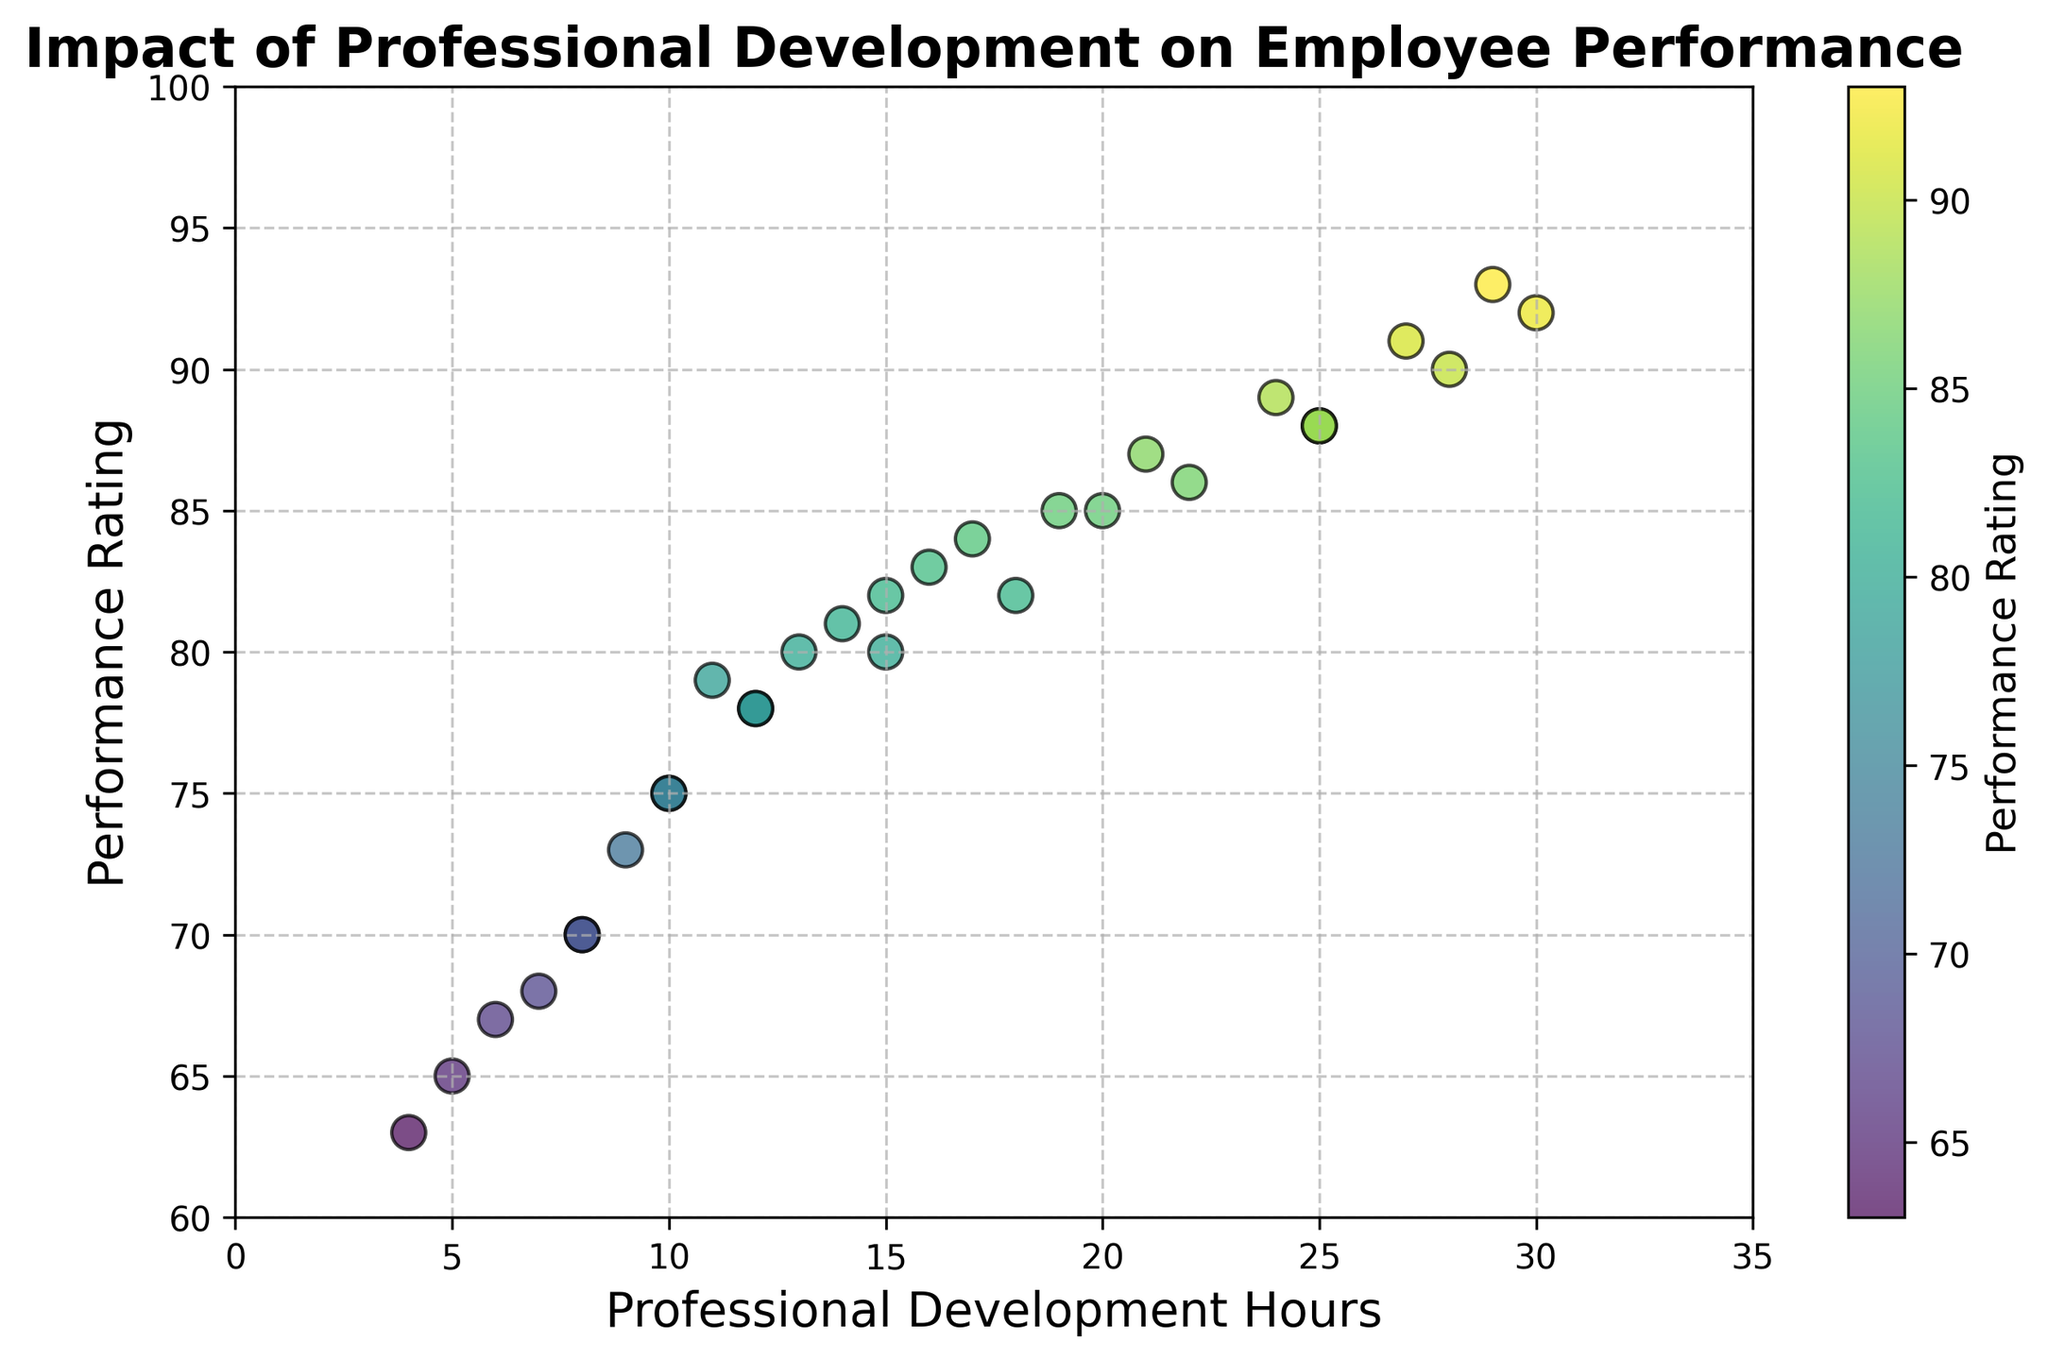How many employees have a performance rating above 85? By examining the y-axis and identifying points above the 85 mark, we count the number of points.
Answer: 8 Is there a noticeable trend between professional development hours and performance ratings? When looking at the scatter plot, you can see that as professional development hours increase (x-axis), the performance ratings (y-axis) generally also increase, indicating a positive relationship.
Answer: Yes, a positive trend Which employee had the highest performance rating and how many professional development hours did they complete? The highest performance rating on the y-axis is 93. Checking the corresponding x-axis value gives the number of professional development hours.
Answer: Employee with 29 hours What is the average performance rating for employees who completed at least 20 hours of professional development? Identify and sum the performance ratings of employees with 20+ hours of development, then divide by the count. Ratings: [85, 88, 92, 86, 88, 87, 89, 91, 93]. The sum is 709 and there are 9 employees, so 709/9 = 78.78
Answer: 88.67 Comparing employees with 10 hours and 25 hours of professional development, which group had higher average performance ratings? Look at the ratings for employees with exactly 10 hours (75, 75) and employees with exactly 25 hours (88, 88). Average for 10 hours: (75+75)/2 = 75, for 25 hours: (88+88)/2 = 88.
Answer: 25 hours group What is the range of professional development hours for employees with performance ratings between 80 and 85? Identify employees with performance ratings between 80 and 85, then find the minimum and maximum development hours: Ratings: [80, 80, 81, 82, 83, 84, 85, 85], Hours are [15, 13, 14, 18, 16, 17, 20, 19], range = 20-13.
Answer: 7 hours Which employee had the lowest performance rating and how many hours of professional development did they complete? The lowest performance rating on the y-axis is 63. Checking the corresponding x-axis value gives the number of professional development hours.
Answer: Employee with 4 hours How does the density of points vary with respect to professional development hours? Visually scanning from left to right along the x-axis, we notice a higher concentration of points between 10 and 20 hours, and more sparse before 10 hours and after 25 hours.
Answer: Denser between 10-20 hours What is the combined total of professional development hours for employees with the top three highest performance ratings? Identify the top three ratings: 93, 92, 91, and sum their hours: 29 + 30 + 27 = 86.
Answer: 86 hours 